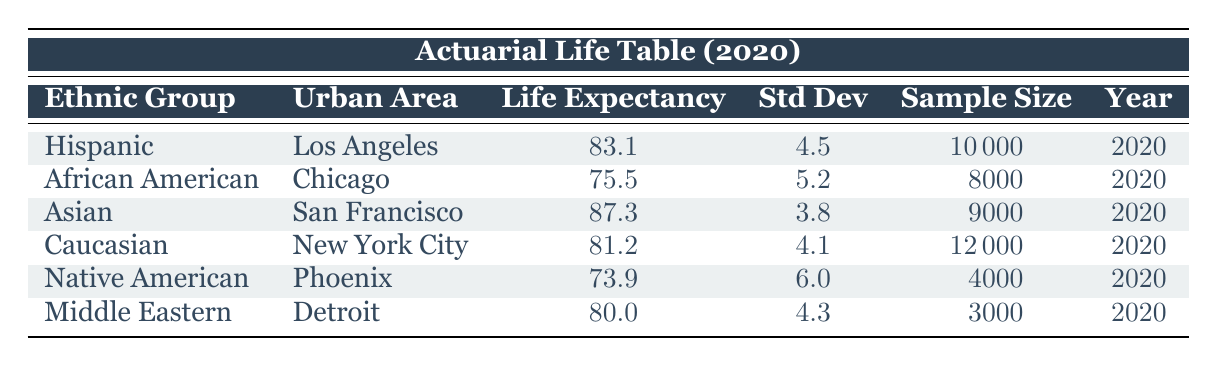What is the life expectancy of the Asian ethnic group in San Francisco? The table clearly lists the life expectancy for the Asian ethnic group in San Francisco as 87.3.
Answer: 87.3 Which ethnic group has the lowest life expectancy in the provided data? By analyzing the life expectancy figures, the Native American group shows the lowest life expectancy of 73.9.
Answer: Native American What is the average life expectancy of all the groups listed in the table? To find the average, we must sum the life expectancies: 83.1 + 75.5 + 87.3 + 81.2 + 73.9 + 80.0 = 481.0. There are 6 groups, so the average is 481.0 / 6 = 80.17.
Answer: 80.17 Is the standard deviation of life expectancy for the Hispanic group equal to 4.5? Yes, the table shows the standard deviation for the Hispanic ethnic group is indeed 4.5.
Answer: Yes How much higher is the life expectancy of the Asian group compared to the African American group? We find the life expectancy of the Asian group is 87.3, and for the African American group it is 75.5. The difference is 87.3 - 75.5 = 11.8.
Answer: 11.8 What is the life expectancy of the Caucasian group and how does it compare to the average life expectancy of all groups? The Caucasian group has a life expectancy of 81.2. The average life expectancy, previously calculated, is 80.17. Comparing them, 81.2 is higher than 80.17 by 1.03.
Answer: 81.2 Which urban area has the highest sample size in the table? Examining the sample sizes, New York City has the highest sample size at 12000.
Answer: New York City Is the life expectancy of the Middle Eastern ethnic group greater than 80? Yes, the life expectancy for the Middle Eastern ethnic group is 80.0, which is indeed equal to 80.
Answer: Yes 